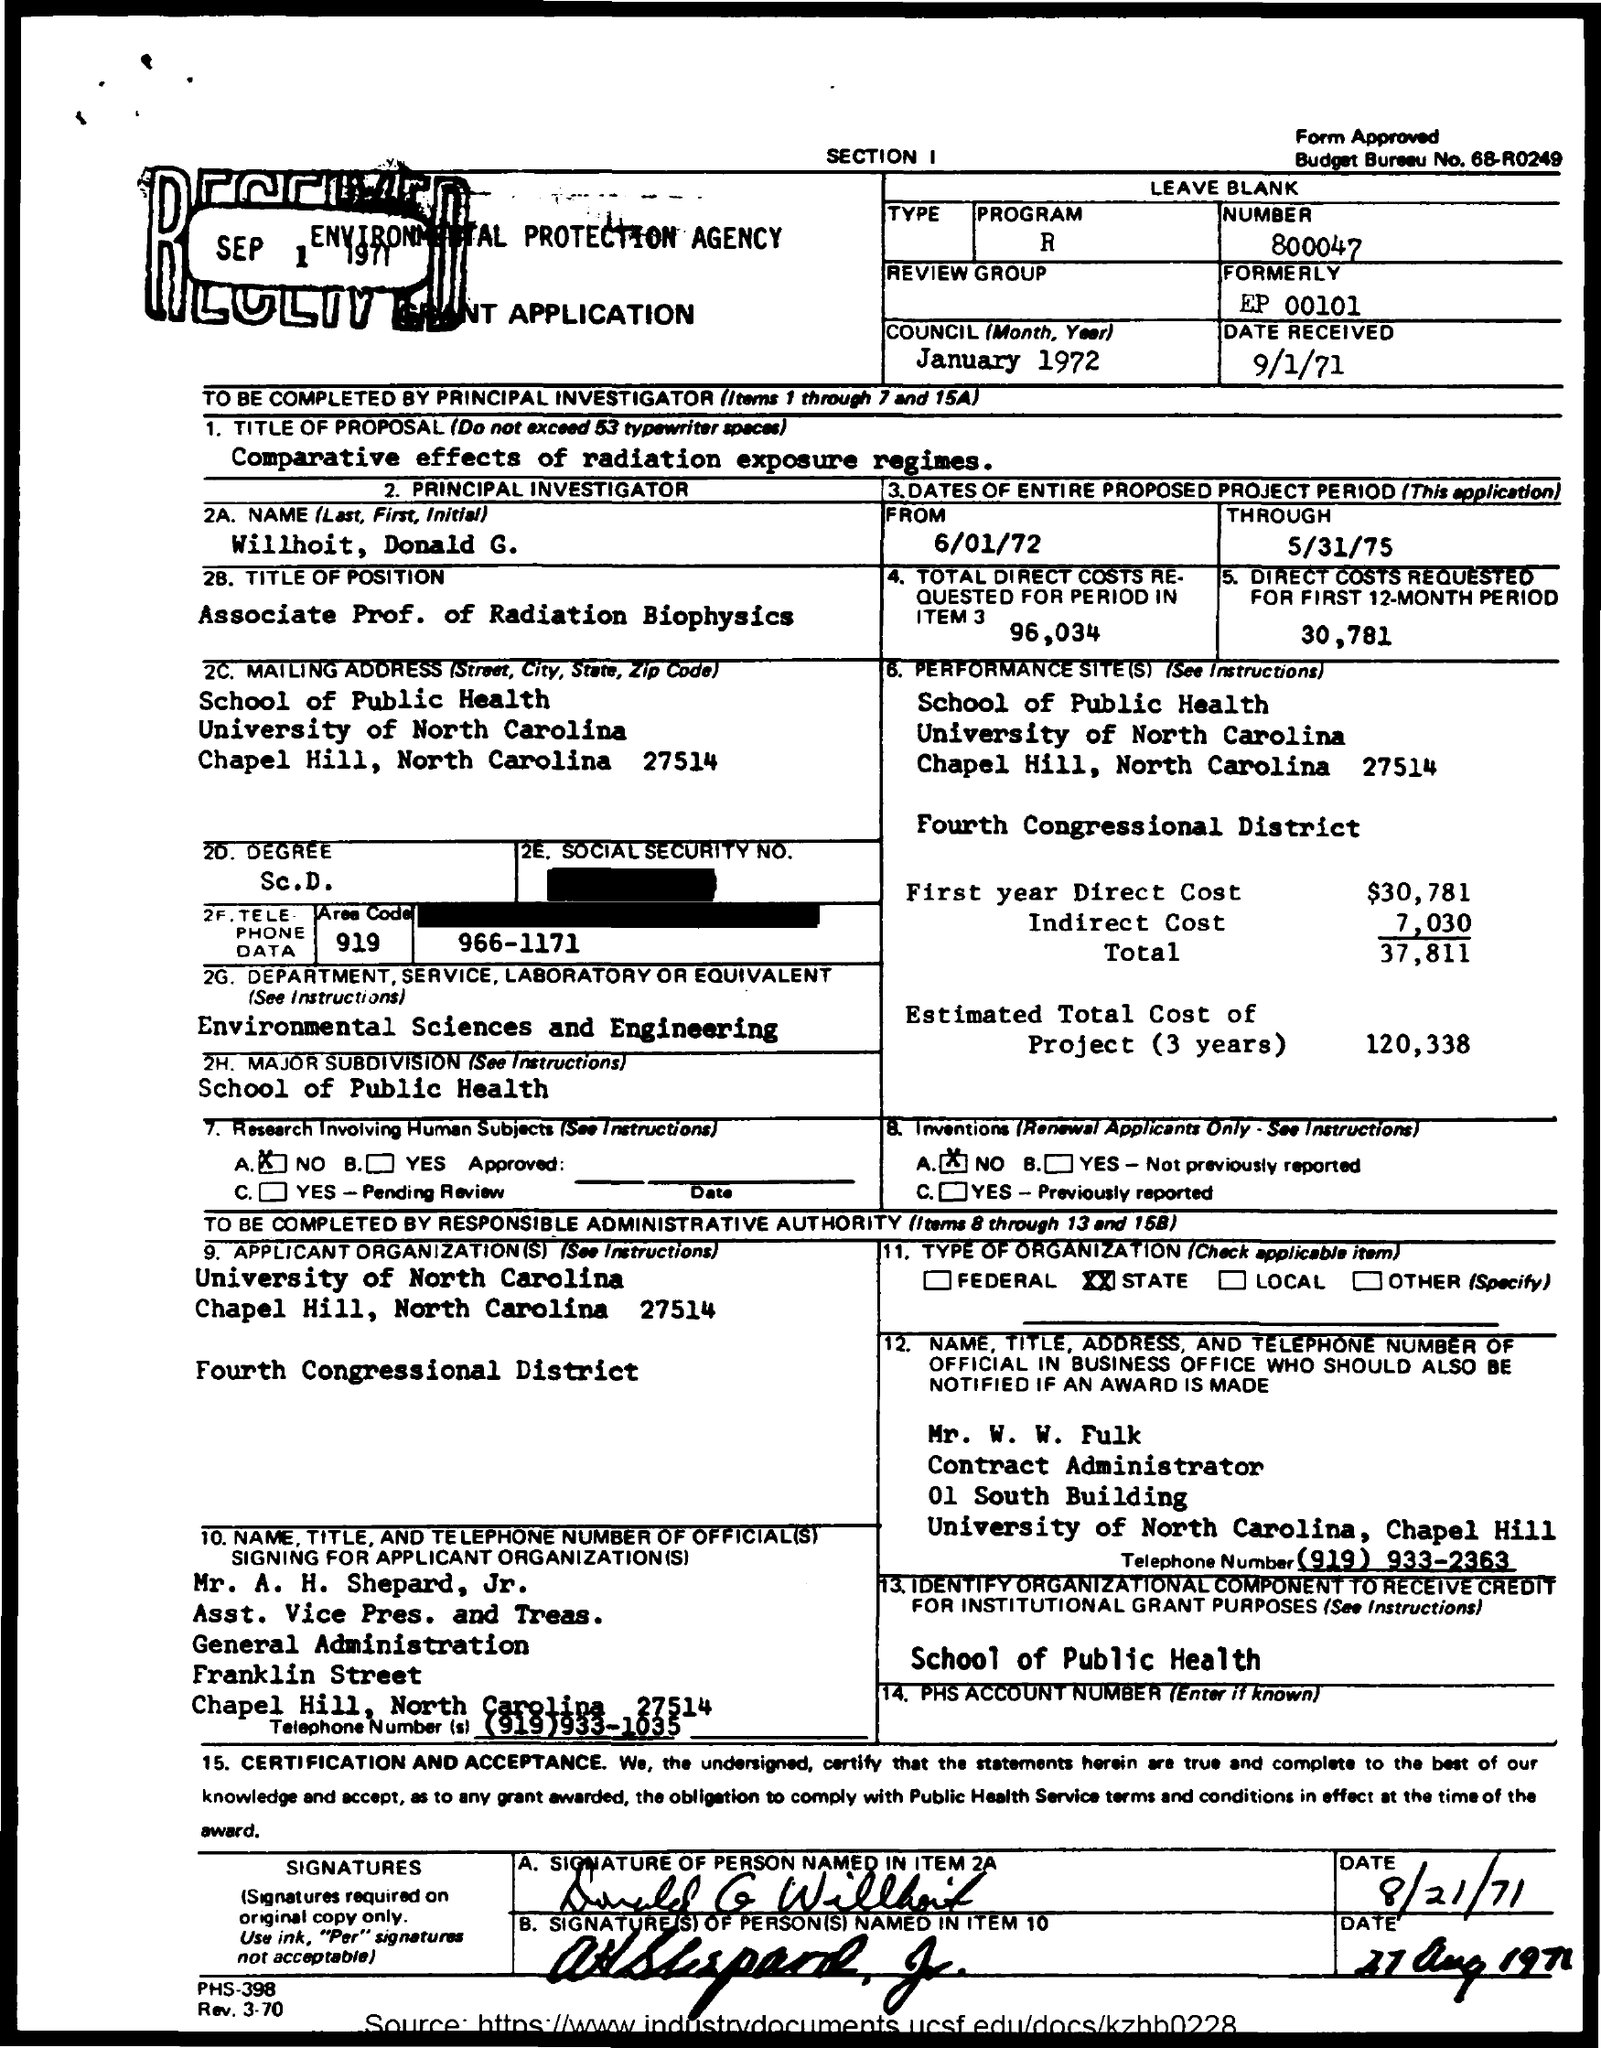Outline some significant characteristics in this image. The received date of the grant application is September 1, 1971. The principal investigator, as per the application, is WILLHOIT, DONALD G. The total direct costs requested for the first 12-month period are 30,781... Willhoit, Donald G. holds the position of Associate Professor of Radiation Biophysics. The estimated total direct cost of the project over a period of three years is 120,338. 